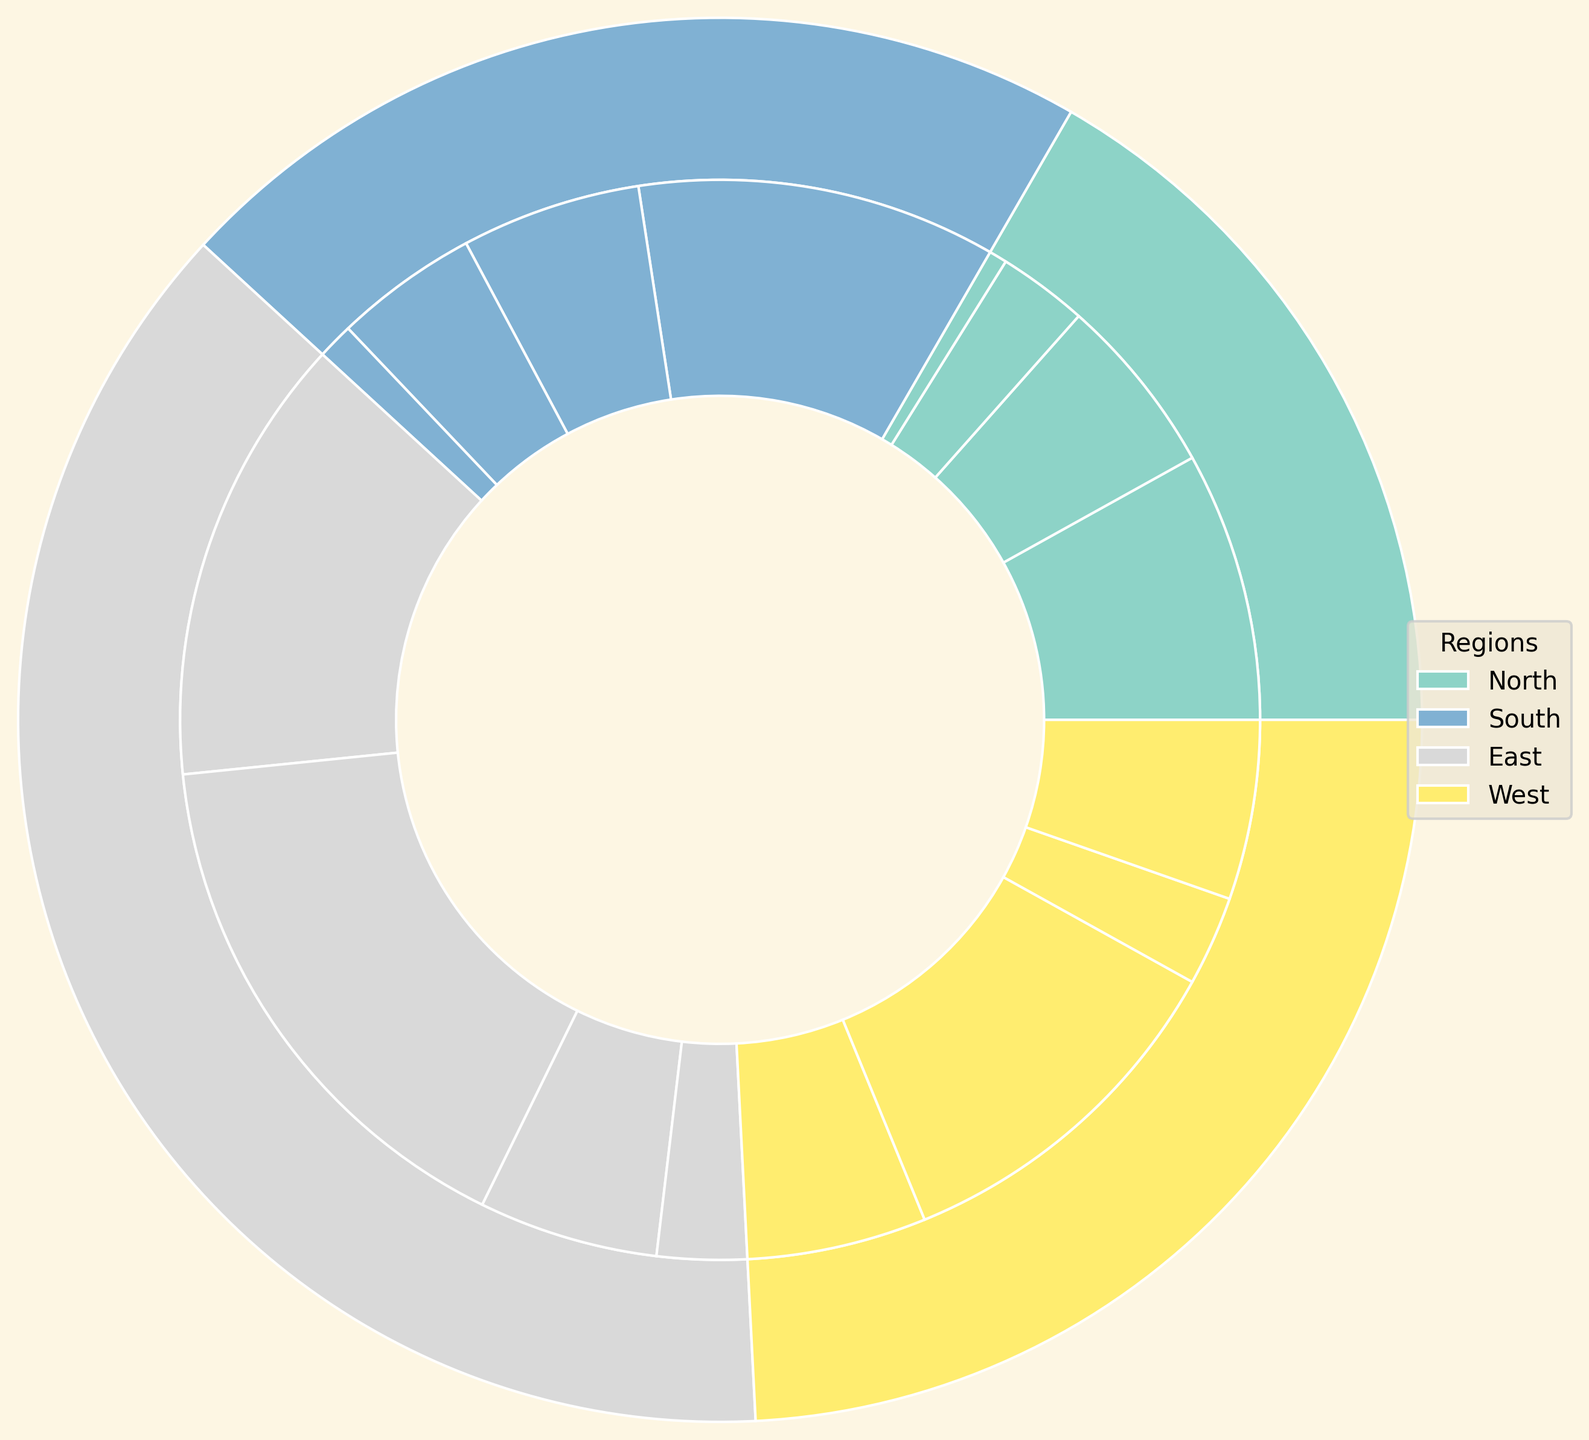What's the total percentage of mineral resources extracted in the North region? To find the total percentage, sum the percentages for each extraction method in the North region: Gold (Open-pit + Underground) = 15 + 10, Silver (Open-pit + Underground) = 5 + 1. Total = 15 + 10 + 5 + 1 = 31
Answer: 31 Which region has the highest percentage of Iron extraction? Compare the total percentages for Iron in each region; only the East and West regions have Iron. East: Surface (10) + Underground (5) = 15. West: Surface (5) + Underground (10) = 15. Both regions have equal percentages for Iron extraction.
Answer: East and West Which extraction method is used more for Coal in the East region, Surface or Underground? Compare the percentages for Surface and Underground methods for Coal in the East: Surface = 25, Underground = 30. Since 30 > 25, Underground is used more.
Answer: Underground How does the total percentage of Silver extraction in the South region compare to the North region? Calculate the total percentage for Silver in both regions and compare: North (Open-pit + Underground) = 5 + 1 = 6, South (Open-pit + Underground) = 8 + 2 = 10. South (10) > North (6).
Answer: South has a higher percentage What's the combined percentage of Gold extraction across all regions? Sum the percentages of Gold extraction from each region: North (Open-pit + Underground) = 15 + 10, South (Open-pit + Underground) = 20 + 10. Combined = 15 + 10 + 20 + 10 = 55.
Answer: 55 Which region has the smallest total percentage of mineral extraction? Compare the outer wedge sizes, which represent the total percentages for each region. The region with the smallest outer wedge is the North (31), considering all others (South, East, West) are higher.
Answer: North How many regions show any percentage of Iron extraction? Identify the regions with sectors representing Iron. Only East and West have Iron extraction segments. Therefore, 2 regions have Iron extraction.
Answer: 2 If the percentage of Surface Coal extraction in the West is increased by 5 percent, which region would have the highest percentage of Surface Coal extraction? Increase the percentage for Surface Coal in the West by 5, making it 10 + 5 = 15. Compare with Surface Coal in the East (25). The East maintains the highest percentage (25).
Answer: East Which mineral has the lowest total percentage of extraction across all regions? Sum the percentages for each mineral across all regions and compare totals: Gold = 55, Silver = 16, Coal = 85 (50+35), Iron = 30 (15+15). Silver has the lowest total (16).
Answer: Silver What's the ratio between Surface and Underground extraction percentages for Coal in the West region? Calculate the ratio by dividing the percentages for Surface and Underground extraction in the West: Surface = 10, Underground = 20. Ratio = 10:20 which simplifies to 1:2.
Answer: 1:2 